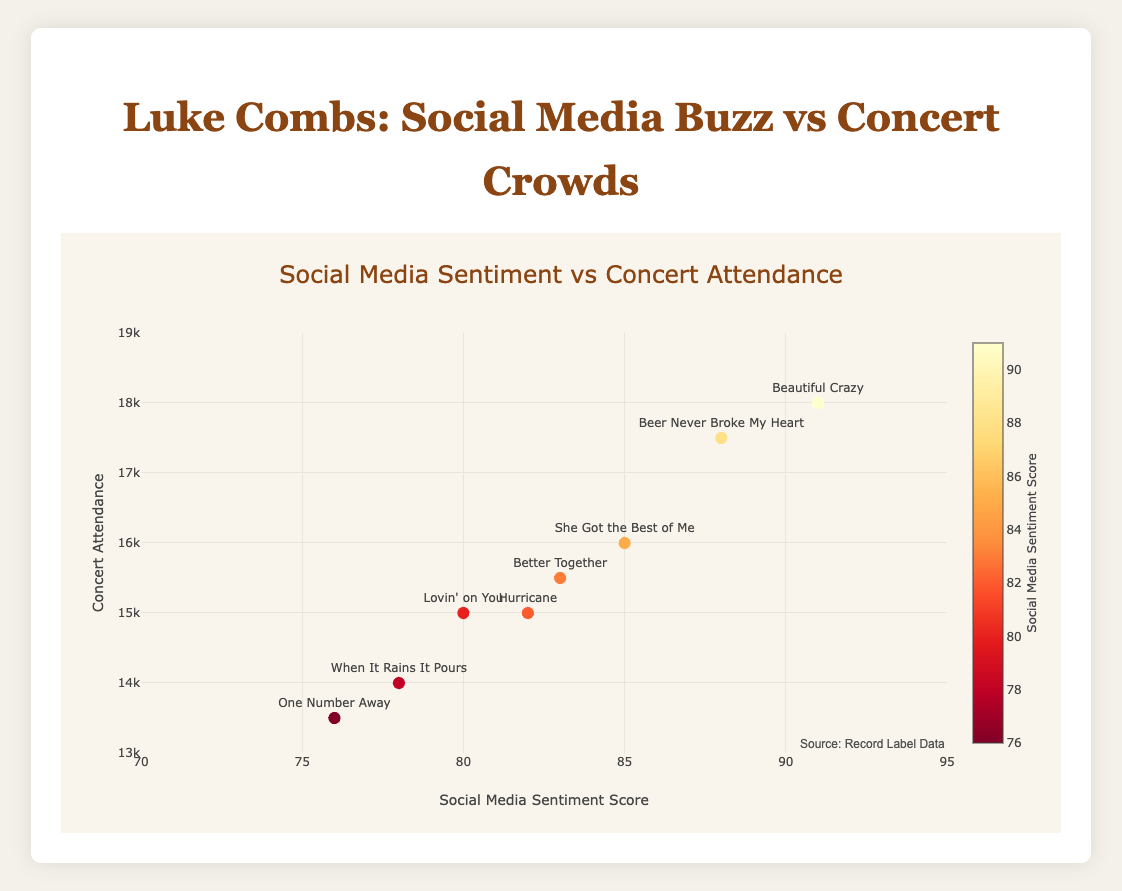Which song has the highest social media sentiment score? The scatter plot shows the sentiment scores on the x-axis. The highest score is the rightmost point on the plot. Identify the song labeled at this point.
Answer: Beautiful Crazy How many songs have a sentiment score higher than 85? Locate and count the data points on the scatter plot that are positioned to the right of the 85 mark on the x-axis.
Answer: 3 What is the total concert attendance for songs with a sentiment score above 80? Identify the data points with sentiment scores above 80 on the x-axis and sum their concert attendance values. (15000 + 18000 + 16000 + 17500 + 15500)
Answer: 82000 Which song has the lowest concert attendance and what is its sentiment score? Find the data point lowest on the y-axis to determine the song. The x-axis value at this point provides the sentiment score.
Answer: One Number Away, 76 How does the concert attendance of "Beer Never Broke My Heart" compare to "Lovin' on You"? Locate both songs on the scatter plot and compare their y-axis values to see which is higher.
Answer: Beer Never Broke My Heart has higher attendance What are the average social media sentiment score and average concert attendance across all songs? Sum all social media sentiment scores and concert attendance values, then divide each sum by the number of songs (average sentiment score: (82 + 91 + 78 + 85 + 88 + 80 + 83 + 76)/8; average concert attendance: (15000 + 18000 + 14000 + 16000 + 17500 + 15000 + 15500 + 13500)/8). (83.375 for sentiment score and 15687.5 for attendance)
Answer: 83.375, 15687.5 Is there a correlation between social media sentiment score and concert attendance? Observe the general trend and direction of the data points on the scatter plot. A positive trend indicates a positive correlation.
Answer: Positive correlation Which song with a sentiment score between 80 and 85 has the highest concert attendance? Identify the data points with sentiment scores between 80 and 85 on the x-axis and compare their concert attendance values to find the highest one.
Answer: She Got the Best of Me What is the range of concert attendance figures for these songs? Identify the highest and lowest y-axis values (concert attendance) and calculate the difference between them. (18000 - 13500)
Answer: 4500 Which song with a sentiment score below 80 had the highest concert attendance? Locate the data points with sentiment scores below 80 on the x-axis and compare their y-axis values (concert attendance) to identify the highest one.
Answer: When It Rains It Pours 